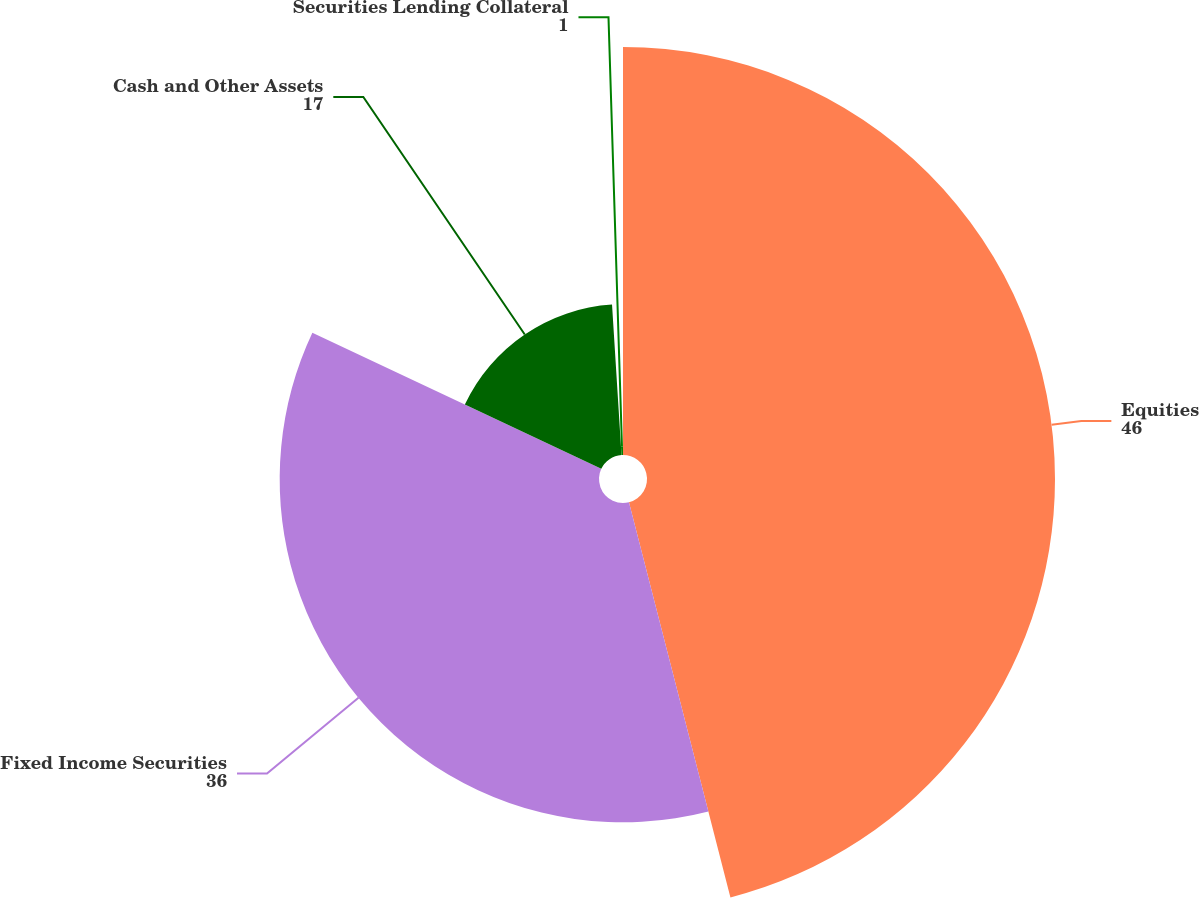Convert chart to OTSL. <chart><loc_0><loc_0><loc_500><loc_500><pie_chart><fcel>Equities<fcel>Fixed Income Securities<fcel>Cash and Other Assets<fcel>Securities Lending Collateral<nl><fcel>46.0%<fcel>36.0%<fcel>17.0%<fcel>1.0%<nl></chart> 